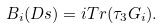<formula> <loc_0><loc_0><loc_500><loc_500>B _ { i } ( D s ) = i T r ( \tau _ { 3 } G _ { i } ) .</formula> 